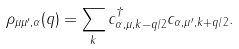<formula> <loc_0><loc_0><loc_500><loc_500>\rho _ { \mu \mu ^ { \prime } , \alpha } ( q ) = \sum _ { k } c ^ { \dagger } _ { \alpha , \mu , k - q / 2 } c _ { \alpha , \mu ^ { \prime } , k + q / 2 } .</formula> 